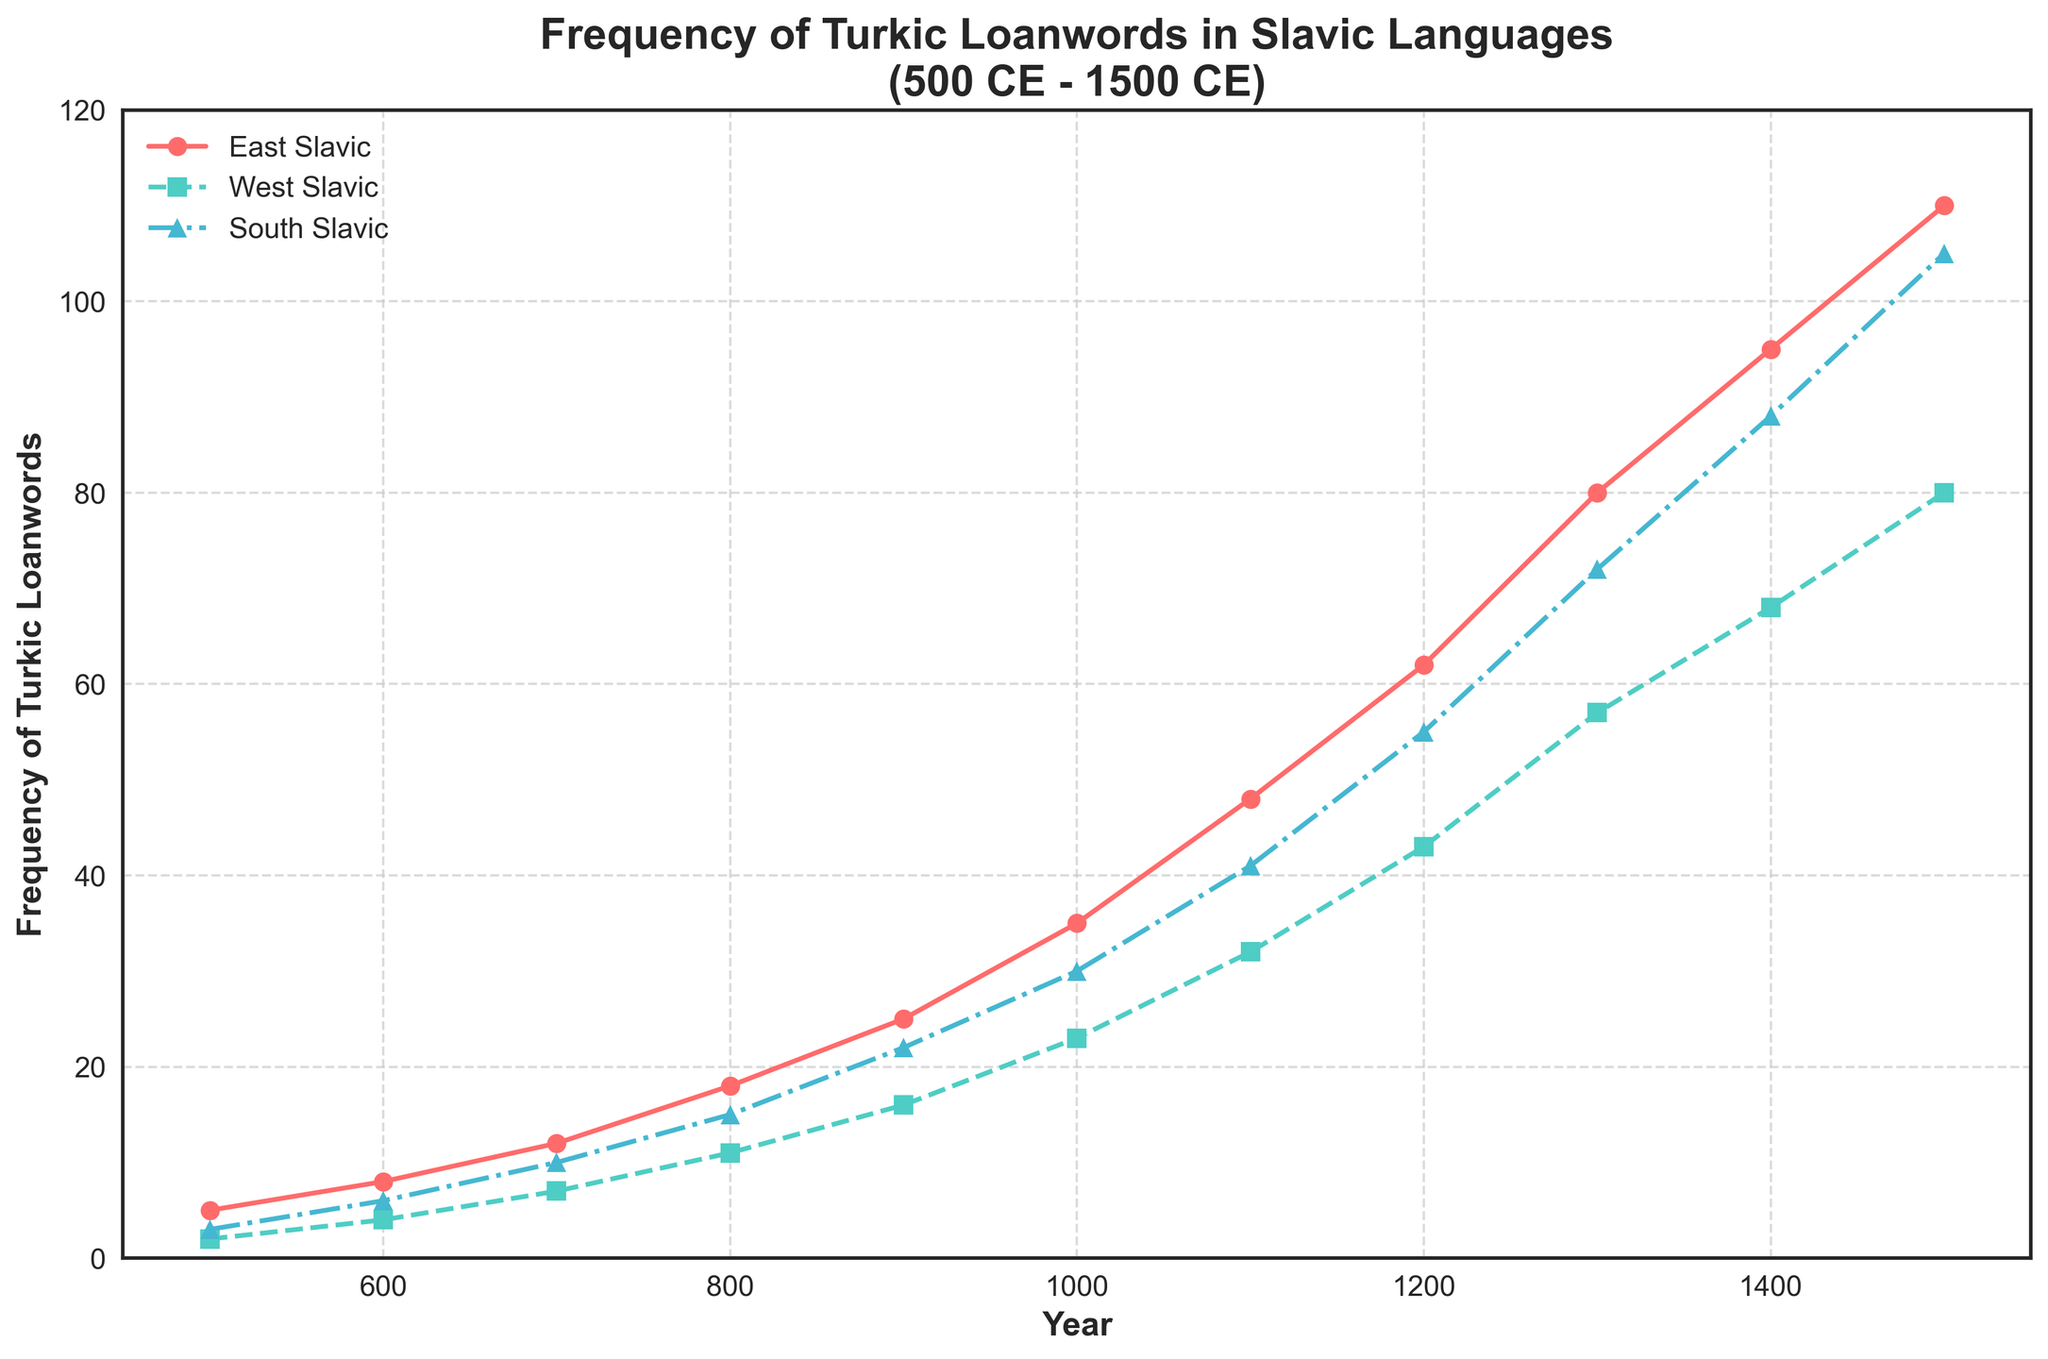How does the frequency of Turkic loanwords in East Slavic languages change from 600 CE to 1000 CE? Look at the red line representing East Slavic languages. At 600 CE, the frequency is 8, and by 1000 CE, it increases to 35. The change is 35 - 8 = 27.
Answer: Increased by 27 Which Slavic group has the highest frequency of Turkic loanwords in 1400 CE? Examine the data points at 1400 CE for each line. East Slavic (red) is at 95, West Slavic (green) is at 68, and South Slavic (blue) is at 88. Therefore, East Slavic has the highest frequency.
Answer: East Slavic What is the average frequency of Turkic loanwords in South Slavic from 500 CE to 1500 CE? Add the frequencies for South Slavic from 500 CE to 1500 CE (3+6+10+15+22+30+41+55+72+88+105 = 447). There are 11 data points, so the average is 447 / 11 = 40.64 (approximately).
Answer: 40.64 Between 1200 CE and 1500 CE, which Slavic group experiences the largest increase in the frequency of Turkic loanwords? Calculate the differences for each group: East Slavic (110-62=48), West Slavic (80-43=37), South Slavic (105-55=50). The largest increase is in South Slavic.
Answer: South Slavic Are there any periods where the frequency of Turkic loanwords in West Slavic remains constant? Check the green line for West Slavic. The frequency consistently increases at each interval, so there are no periods of constancy.
Answer: No What is the difference in the frequency of Turkic loanwords between East Slavic and West Slavic languages in 1300 CE? In 1300 CE, East Slavic has 80 and West Slavic has 57. The difference is 80 - 57 = 23.
Answer: 23 Which year shows an equal frequency of Turkic loanwords between South Slavic and West Slavic languages? By examining the lines for South Slavic (blue) and West Slavic (green), no year shows an identical frequency for both.
Answer: None What is the median frequency of Turkic loanwords in East Slavic languages from 500 CE to 1500 CE? List the frequencies for East Slavic (5, 8, 12, 18, 25, 35, 48, 62, 80, 95, 110). The median is the 6th value in an ordered set, which is 35.
Answer: 35 How does the steepness (rate of change) of the frequency of Turkic loanwords in South Slavic compare to East Slavic from 500 CE to 1500 CE? The blue line for South Slavic and the red line for East Slavic both show increasing trends but the red line has a steeper slope, indicating a faster rate of change.
Answer: East Slavic is steeper In which century do we see the first instance where the frequency of Turkic loanwords in South Slavic exceeds 50? The blue line for South Slavic first exceeds 50 in the 13th century (1200 CE).
Answer: 13th century 